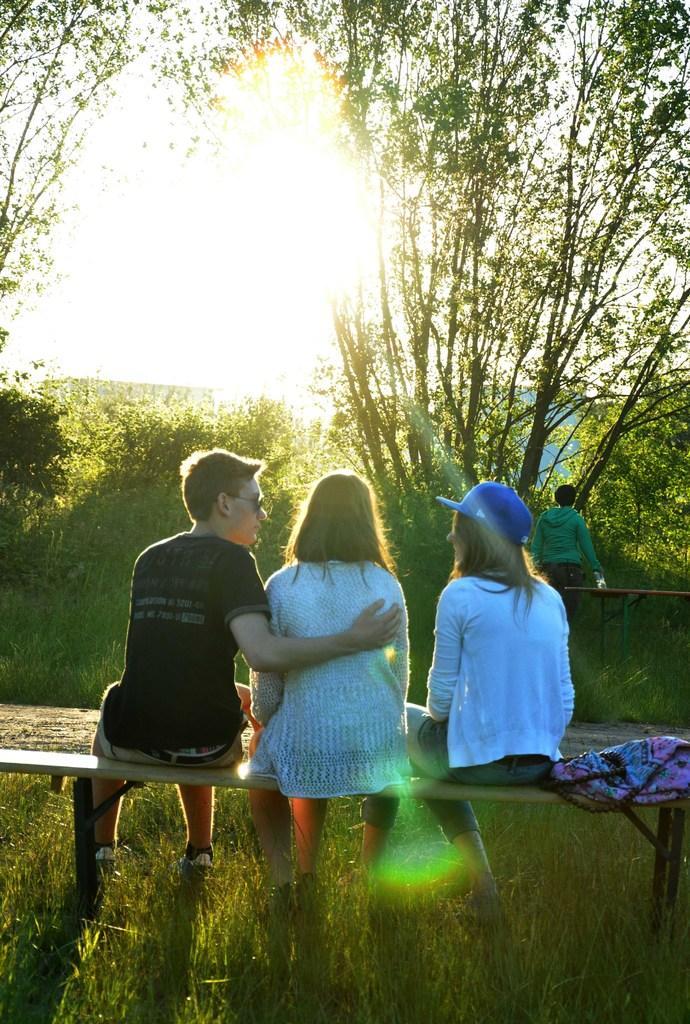Describe this image in one or two sentences. There are three people sitting on the bench. This is the grass. I can see a bag, which is placed on the bench. These are the trees with branches and leaves. I can see a person walking. 